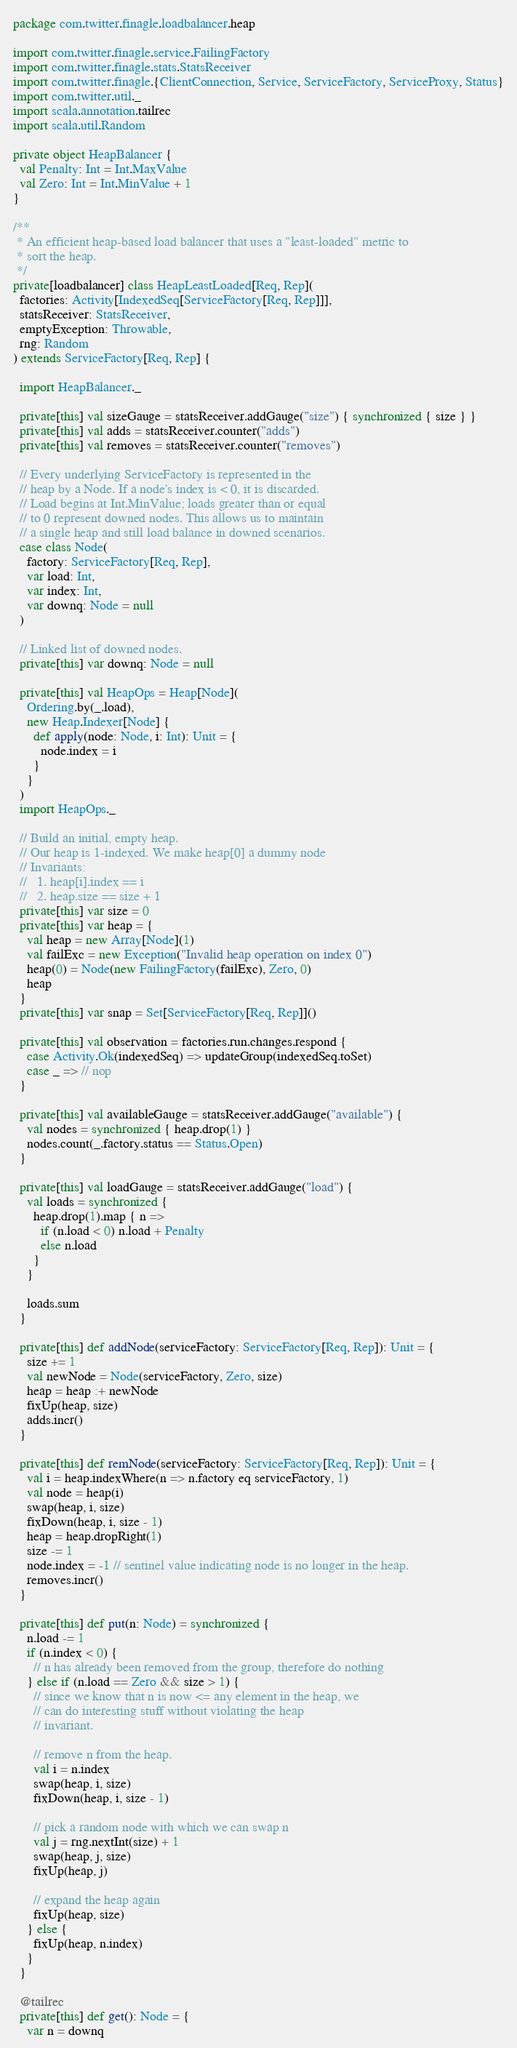<code> <loc_0><loc_0><loc_500><loc_500><_Scala_>package com.twitter.finagle.loadbalancer.heap

import com.twitter.finagle.service.FailingFactory
import com.twitter.finagle.stats.StatsReceiver
import com.twitter.finagle.{ClientConnection, Service, ServiceFactory, ServiceProxy, Status}
import com.twitter.util._
import scala.annotation.tailrec
import scala.util.Random

private object HeapBalancer {
  val Penalty: Int = Int.MaxValue
  val Zero: Int = Int.MinValue + 1
}

/**
 * An efficient heap-based load balancer that uses a "least-loaded" metric to
 * sort the heap.
 */
private[loadbalancer] class HeapLeastLoaded[Req, Rep](
  factories: Activity[IndexedSeq[ServiceFactory[Req, Rep]]],
  statsReceiver: StatsReceiver,
  emptyException: Throwable,
  rng: Random
) extends ServiceFactory[Req, Rep] {

  import HeapBalancer._

  private[this] val sizeGauge = statsReceiver.addGauge("size") { synchronized { size } }
  private[this] val adds = statsReceiver.counter("adds")
  private[this] val removes = statsReceiver.counter("removes")

  // Every underlying ServiceFactory is represented in the
  // heap by a Node. If a node's index is < 0, it is discarded.
  // Load begins at Int.MinValue; loads greater than or equal
  // to 0 represent downed nodes. This allows us to maintain
  // a single heap and still load balance in downed scenarios.
  case class Node(
    factory: ServiceFactory[Req, Rep],
    var load: Int,
    var index: Int,
    var downq: Node = null
  )

  // Linked list of downed nodes.
  private[this] var downq: Node = null

  private[this] val HeapOps = Heap[Node](
    Ordering.by(_.load),
    new Heap.Indexer[Node] {
      def apply(node: Node, i: Int): Unit = {
        node.index = i
      }
    }
  )
  import HeapOps._

  // Build an initial, empty heap.
  // Our heap is 1-indexed. We make heap[0] a dummy node
  // Invariants:
  //   1. heap[i].index == i
  //   2. heap.size == size + 1
  private[this] var size = 0
  private[this] var heap = {
    val heap = new Array[Node](1)
    val failExc = new Exception("Invalid heap operation on index 0")
    heap(0) = Node(new FailingFactory(failExc), Zero, 0)
    heap
  }
  private[this] var snap = Set[ServiceFactory[Req, Rep]]()

  private[this] val observation = factories.run.changes.respond {
    case Activity.Ok(indexedSeq) => updateGroup(indexedSeq.toSet)
    case _ => // nop
  }

  private[this] val availableGauge = statsReceiver.addGauge("available") {
    val nodes = synchronized { heap.drop(1) }
    nodes.count(_.factory.status == Status.Open)
  }

  private[this] val loadGauge = statsReceiver.addGauge("load") {
    val loads = synchronized {
      heap.drop(1).map { n =>
        if (n.load < 0) n.load + Penalty
        else n.load
      }
    }

    loads.sum
  }

  private[this] def addNode(serviceFactory: ServiceFactory[Req, Rep]): Unit = {
    size += 1
    val newNode = Node(serviceFactory, Zero, size)
    heap = heap :+ newNode
    fixUp(heap, size)
    adds.incr()
  }

  private[this] def remNode(serviceFactory: ServiceFactory[Req, Rep]): Unit = {
    val i = heap.indexWhere(n => n.factory eq serviceFactory, 1)
    val node = heap(i)
    swap(heap, i, size)
    fixDown(heap, i, size - 1)
    heap = heap.dropRight(1)
    size -= 1
    node.index = -1 // sentinel value indicating node is no longer in the heap.
    removes.incr()
  }

  private[this] def put(n: Node) = synchronized {
    n.load -= 1
    if (n.index < 0) {
      // n has already been removed from the group, therefore do nothing
    } else if (n.load == Zero && size > 1) {
      // since we know that n is now <= any element in the heap, we
      // can do interesting stuff without violating the heap
      // invariant.

      // remove n from the heap.
      val i = n.index
      swap(heap, i, size)
      fixDown(heap, i, size - 1)

      // pick a random node with which we can swap n
      val j = rng.nextInt(size) + 1
      swap(heap, j, size)
      fixUp(heap, j)

      // expand the heap again
      fixUp(heap, size)
    } else {
      fixUp(heap, n.index)
    }
  }

  @tailrec
  private[this] def get(): Node = {
    var n = downq</code> 